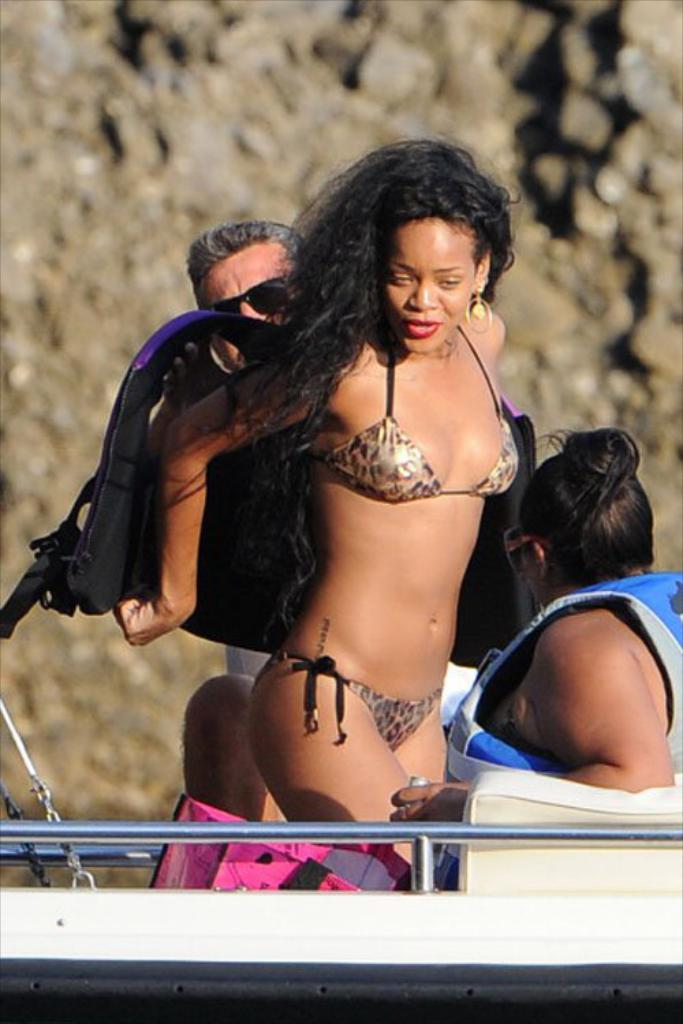How many people are in the image? There are three persons in the image. Can you describe the position of the woman in the group? The woman is in the middle of the group. What is the woman wearing in the image? The woman is wearing a jacket. What type of setting is depicted in the image? The image appears to depict a boat at the bottom. What type of stove can be seen in the image? There is no stove present in the image. How many hands does the woman have in the image? The number of hands cannot be determined from the image, as it only shows the woman's jacket and not her hands. 